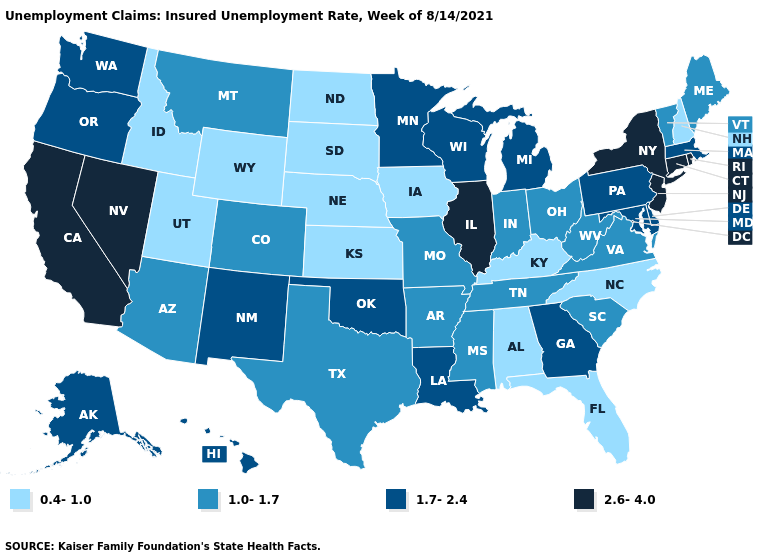Name the states that have a value in the range 1.7-2.4?
Answer briefly. Alaska, Delaware, Georgia, Hawaii, Louisiana, Maryland, Massachusetts, Michigan, Minnesota, New Mexico, Oklahoma, Oregon, Pennsylvania, Washington, Wisconsin. What is the value of Colorado?
Answer briefly. 1.0-1.7. What is the highest value in the Northeast ?
Keep it brief. 2.6-4.0. Does Wisconsin have a lower value than California?
Short answer required. Yes. Name the states that have a value in the range 1.0-1.7?
Give a very brief answer. Arizona, Arkansas, Colorado, Indiana, Maine, Mississippi, Missouri, Montana, Ohio, South Carolina, Tennessee, Texas, Vermont, Virginia, West Virginia. Does Vermont have a higher value than Tennessee?
Quick response, please. No. What is the value of Oregon?
Be succinct. 1.7-2.4. Does Utah have the lowest value in the USA?
Short answer required. Yes. Is the legend a continuous bar?
Be succinct. No. Among the states that border Arizona , does Colorado have the highest value?
Short answer required. No. What is the lowest value in the Northeast?
Short answer required. 0.4-1.0. Among the states that border Iowa , does Illinois have the highest value?
Answer briefly. Yes. Name the states that have a value in the range 0.4-1.0?
Give a very brief answer. Alabama, Florida, Idaho, Iowa, Kansas, Kentucky, Nebraska, New Hampshire, North Carolina, North Dakota, South Dakota, Utah, Wyoming. Among the states that border Montana , which have the highest value?
Be succinct. Idaho, North Dakota, South Dakota, Wyoming. What is the value of California?
Quick response, please. 2.6-4.0. 